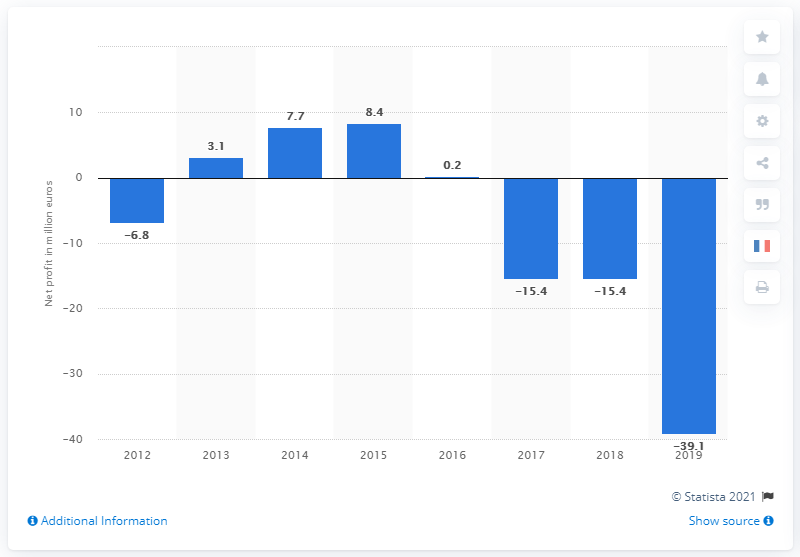List a handful of essential elements in this visual. In 2015, the profit of Al's Groupe was 8.4 million. 